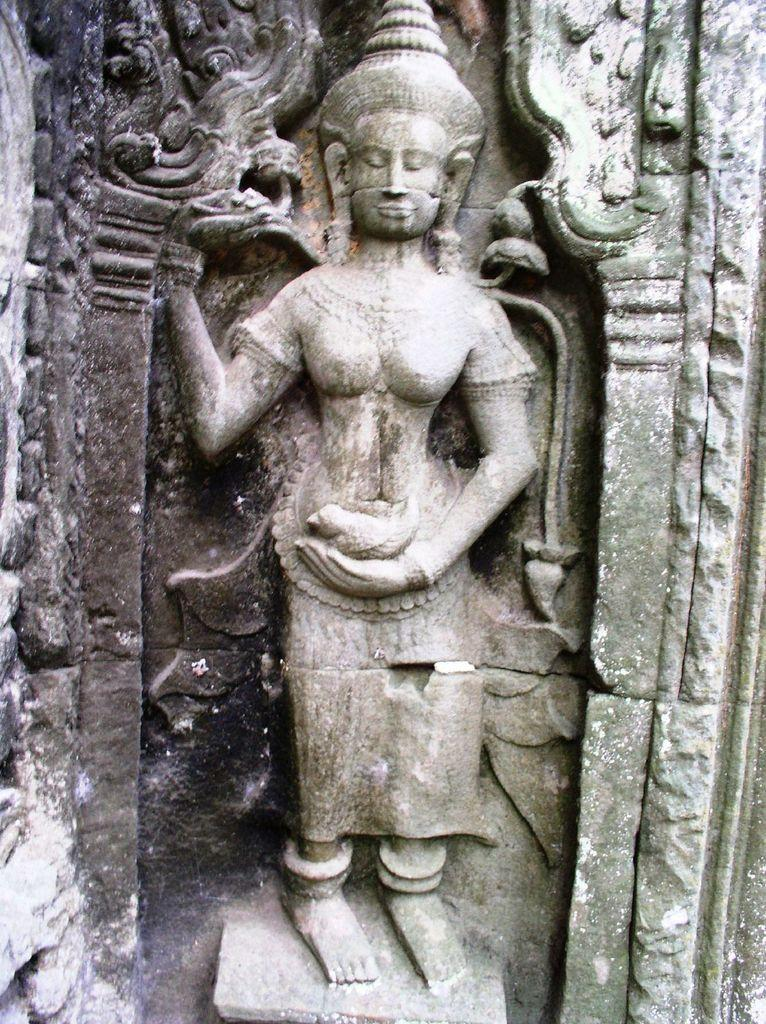What is the main subject of the image? There is a sculpture of a person in the image. Can you describe the sculpture in more detail? Unfortunately, the provided facts do not give any additional details about the sculpture. What might the sculpture be made of? The material used to create the sculpture is not mentioned in the given facts. How many squirrels are sitting on the person's shoulders in the image? There are no squirrels present in the image; it features a sculpture of a person. 